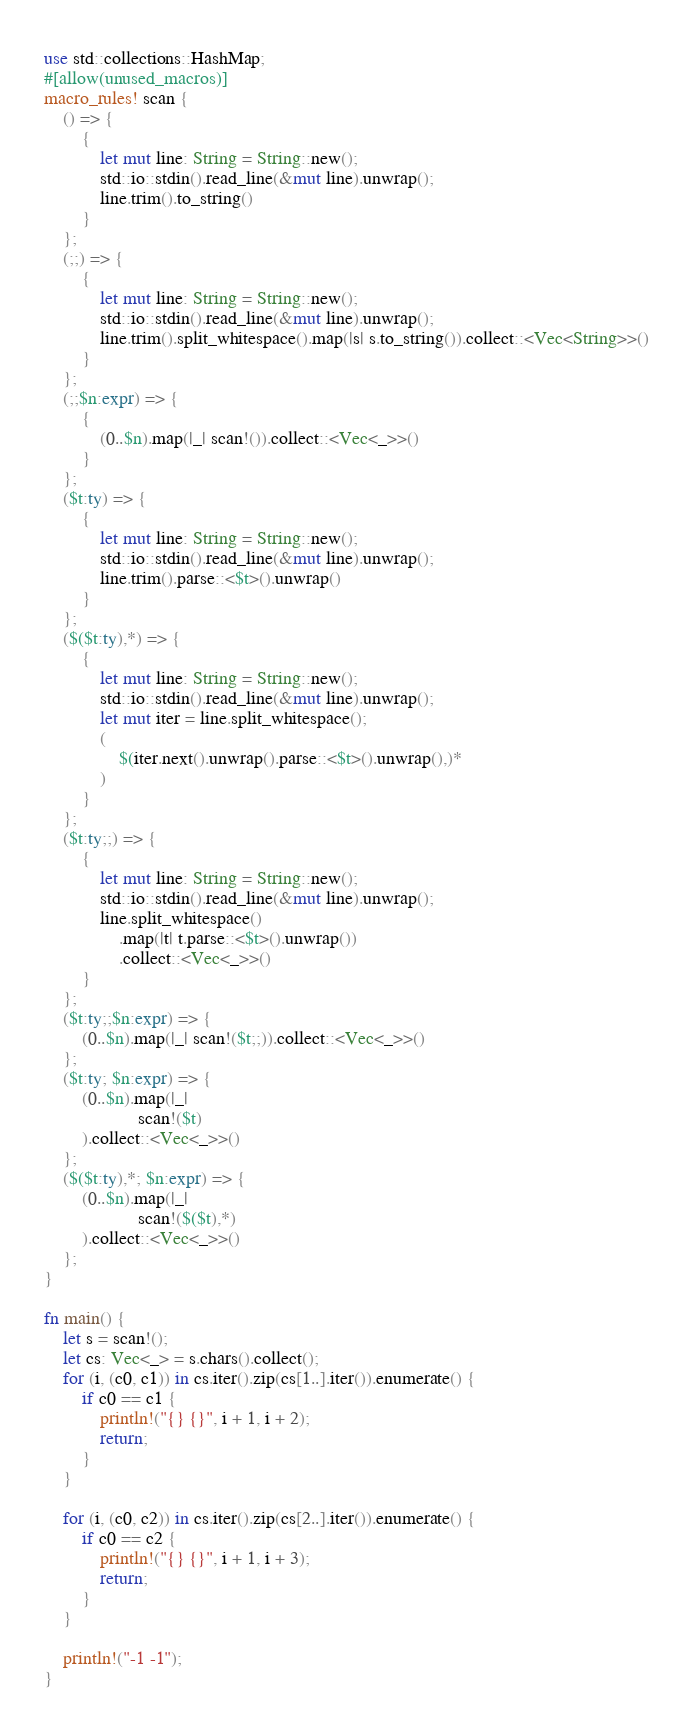Convert code to text. <code><loc_0><loc_0><loc_500><loc_500><_Rust_>use std::collections::HashMap;
#[allow(unused_macros)]
macro_rules! scan {
    () => {
        {
            let mut line: String = String::new();
            std::io::stdin().read_line(&mut line).unwrap();
            line.trim().to_string()
        }
    };
    (;;) => {
        {
            let mut line: String = String::new();
            std::io::stdin().read_line(&mut line).unwrap();
            line.trim().split_whitespace().map(|s| s.to_string()).collect::<Vec<String>>()
        }
    };
    (;;$n:expr) => {
        {
            (0..$n).map(|_| scan!()).collect::<Vec<_>>()
        }
    };
    ($t:ty) => {
        {
            let mut line: String = String::new();
            std::io::stdin().read_line(&mut line).unwrap();
            line.trim().parse::<$t>().unwrap()
        }
    };
    ($($t:ty),*) => {
        {
            let mut line: String = String::new();
            std::io::stdin().read_line(&mut line).unwrap();
            let mut iter = line.split_whitespace();
            (
                $(iter.next().unwrap().parse::<$t>().unwrap(),)*
            )
        }
    };
    ($t:ty;;) => {
        {
            let mut line: String = String::new();
            std::io::stdin().read_line(&mut line).unwrap();
            line.split_whitespace()
                .map(|t| t.parse::<$t>().unwrap())
                .collect::<Vec<_>>()
        }
    };
    ($t:ty;;$n:expr) => {
        (0..$n).map(|_| scan!($t;;)).collect::<Vec<_>>()
    };
    ($t:ty; $n:expr) => {
        (0..$n).map(|_|
                    scan!($t)
        ).collect::<Vec<_>>()
    };
    ($($t:ty),*; $n:expr) => {
        (0..$n).map(|_|
                    scan!($($t),*)
        ).collect::<Vec<_>>()
    };
}

fn main() {
    let s = scan!();
    let cs: Vec<_> = s.chars().collect();
    for (i, (c0, c1)) in cs.iter().zip(cs[1..].iter()).enumerate() {
        if c0 == c1 {
            println!("{} {}", i + 1, i + 2);
            return;
        }
    }

    for (i, (c0, c2)) in cs.iter().zip(cs[2..].iter()).enumerate() {
        if c0 == c2 {
            println!("{} {}", i + 1, i + 3);
            return;
        }
    }

    println!("-1 -1");
}
</code> 